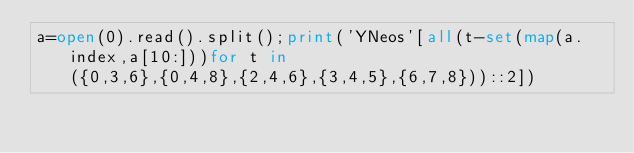Convert code to text. <code><loc_0><loc_0><loc_500><loc_500><_Python_>a=open(0).read().split();print('YNeos'[all(t-set(map(a.index,a[10:]))for t in({0,3,6},{0,4,8},{2,4,6},{3,4,5},{6,7,8}))::2])</code> 